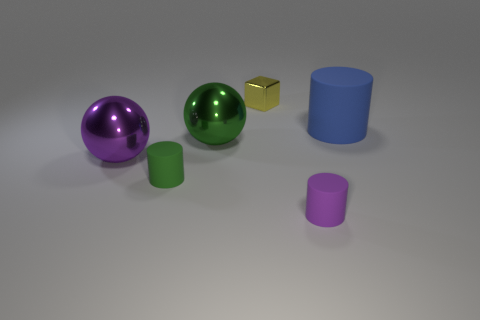How many objects in the image are not spherical? There are four objects that are not spherical: two cylinders, one cube, and one object that looks like a small plate or a very shallow cylinder. What colors are these non-spherical objects? The non-spherical objects include a blue cylinder, a green cylinder, a gold cube, and a purple shallow cylinder or plate. 